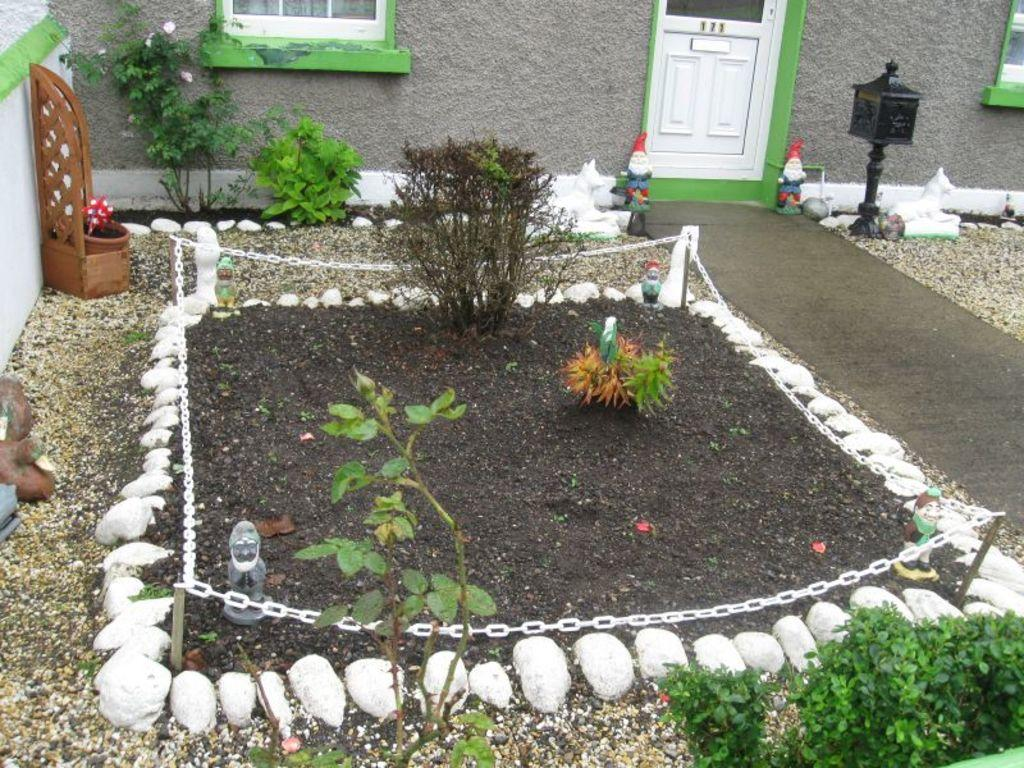What type of natural elements can be seen in the image? There are stones and mud in the image. What architectural features are present in the image? There is a door and a window in the image. What type of vegetation is visible in the image? There are plants in the image. What man-made structure can be seen in the image? There is a road in the image. Can you hear the sound of a boy playing in the image? There is no boy or sound present in the image. What level of expertise is required to begin using the plants in the image? The image does not provide information about the level of expertise required to use the plants, and there is no indication that the plants are meant to be used. 